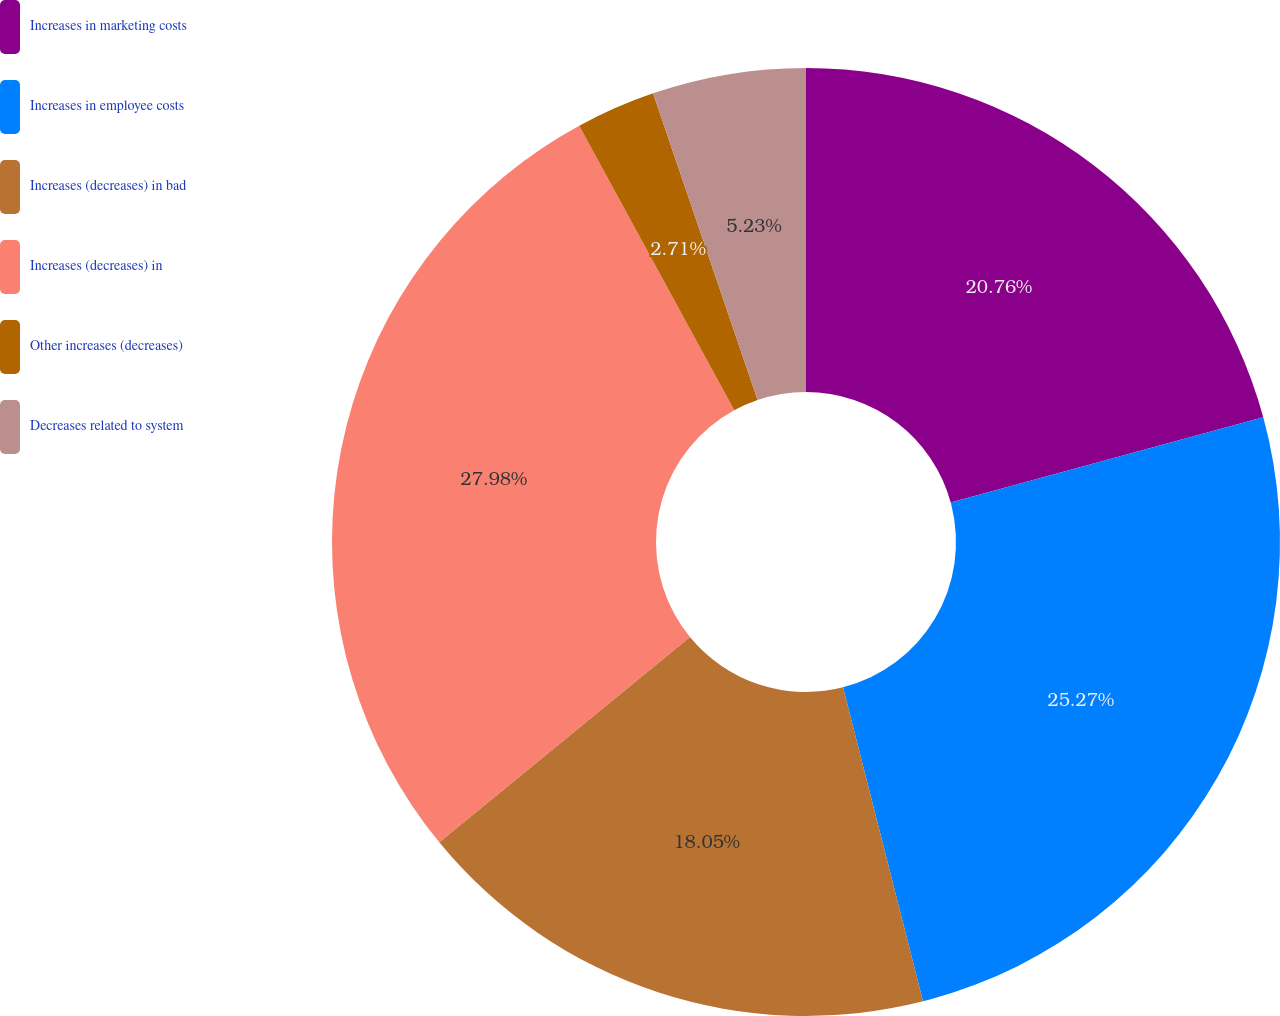Convert chart. <chart><loc_0><loc_0><loc_500><loc_500><pie_chart><fcel>Increases in marketing costs<fcel>Increases in employee costs<fcel>Increases (decreases) in bad<fcel>Increases (decreases) in<fcel>Other increases (decreases)<fcel>Decreases related to system<nl><fcel>20.76%<fcel>25.27%<fcel>18.05%<fcel>27.98%<fcel>2.71%<fcel>5.23%<nl></chart> 